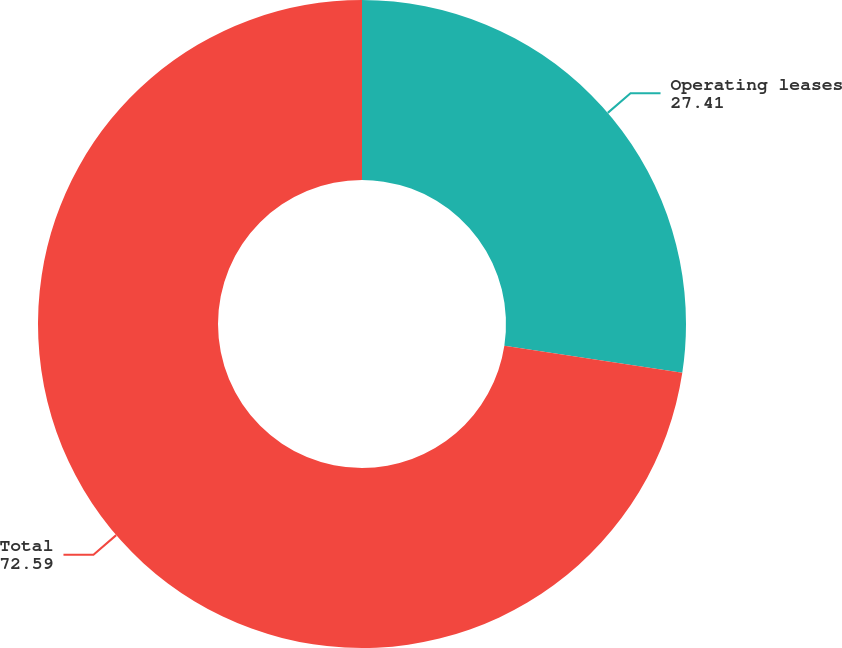Convert chart to OTSL. <chart><loc_0><loc_0><loc_500><loc_500><pie_chart><fcel>Operating leases<fcel>Total<nl><fcel>27.41%<fcel>72.59%<nl></chart> 